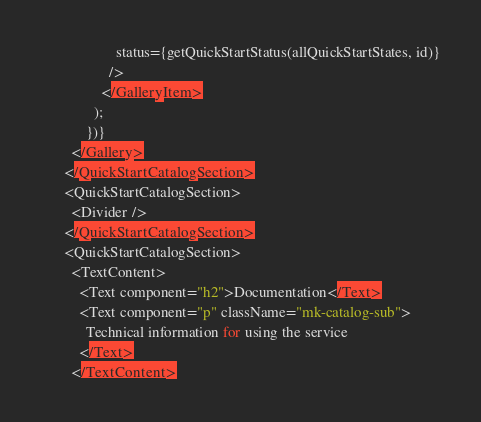<code> <loc_0><loc_0><loc_500><loc_500><_TypeScript_>                    status={getQuickStartStatus(allQuickStartStates, id)}
                  />
                </GalleryItem>
              );
            })}
        </Gallery>
      </QuickStartCatalogSection>
      <QuickStartCatalogSection>
        <Divider />
      </QuickStartCatalogSection>
      <QuickStartCatalogSection>
        <TextContent>
          <Text component="h2">Documentation</Text>
          <Text component="p" className="mk-catalog-sub">
            Technical information for using the service
          </Text>
        </TextContent></code> 